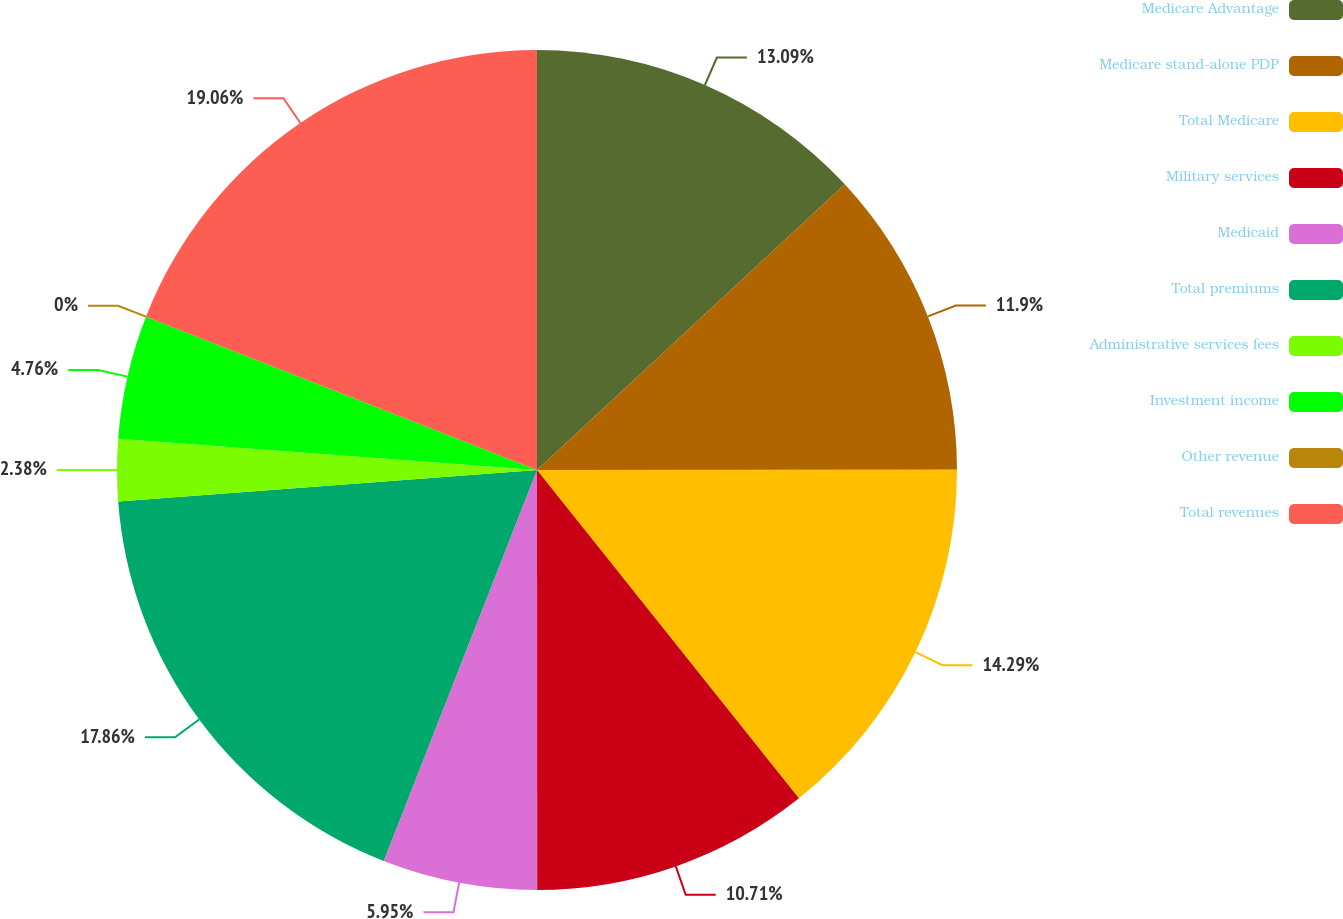<chart> <loc_0><loc_0><loc_500><loc_500><pie_chart><fcel>Medicare Advantage<fcel>Medicare stand-alone PDP<fcel>Total Medicare<fcel>Military services<fcel>Medicaid<fcel>Total premiums<fcel>Administrative services fees<fcel>Investment income<fcel>Other revenue<fcel>Total revenues<nl><fcel>13.09%<fcel>11.9%<fcel>14.29%<fcel>10.71%<fcel>5.95%<fcel>17.86%<fcel>2.38%<fcel>4.76%<fcel>0.0%<fcel>19.05%<nl></chart> 